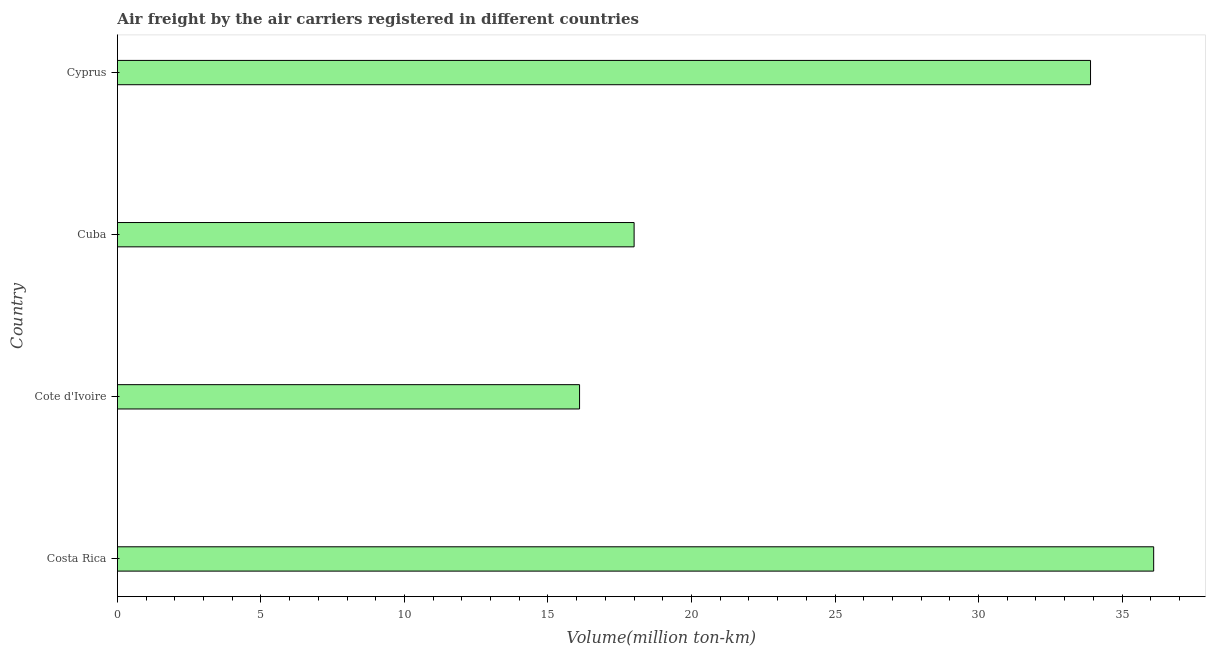What is the title of the graph?
Provide a succinct answer. Air freight by the air carriers registered in different countries. What is the label or title of the X-axis?
Keep it short and to the point. Volume(million ton-km). What is the air freight in Cote d'Ivoire?
Make the answer very short. 16.1. Across all countries, what is the maximum air freight?
Offer a terse response. 36.1. Across all countries, what is the minimum air freight?
Your answer should be compact. 16.1. In which country was the air freight minimum?
Make the answer very short. Cote d'Ivoire. What is the sum of the air freight?
Keep it short and to the point. 104.1. What is the difference between the air freight in Cote d'Ivoire and Cyprus?
Provide a short and direct response. -17.8. What is the average air freight per country?
Provide a succinct answer. 26.02. What is the median air freight?
Your response must be concise. 25.95. In how many countries, is the air freight greater than 2 million ton-km?
Ensure brevity in your answer.  4. What is the ratio of the air freight in Cote d'Ivoire to that in Cuba?
Give a very brief answer. 0.89. Is the air freight in Cote d'Ivoire less than that in Cyprus?
Provide a short and direct response. Yes. What is the difference between the highest and the second highest air freight?
Provide a succinct answer. 2.2. In how many countries, is the air freight greater than the average air freight taken over all countries?
Offer a very short reply. 2. How many bars are there?
Your answer should be compact. 4. Are all the bars in the graph horizontal?
Your response must be concise. Yes. What is the difference between two consecutive major ticks on the X-axis?
Give a very brief answer. 5. Are the values on the major ticks of X-axis written in scientific E-notation?
Provide a succinct answer. No. What is the Volume(million ton-km) in Costa Rica?
Provide a short and direct response. 36.1. What is the Volume(million ton-km) in Cote d'Ivoire?
Make the answer very short. 16.1. What is the Volume(million ton-km) in Cyprus?
Keep it short and to the point. 33.9. What is the difference between the Volume(million ton-km) in Costa Rica and Cote d'Ivoire?
Your response must be concise. 20. What is the difference between the Volume(million ton-km) in Costa Rica and Cuba?
Provide a short and direct response. 18.1. What is the difference between the Volume(million ton-km) in Cote d'Ivoire and Cuba?
Provide a short and direct response. -1.9. What is the difference between the Volume(million ton-km) in Cote d'Ivoire and Cyprus?
Offer a terse response. -17.8. What is the difference between the Volume(million ton-km) in Cuba and Cyprus?
Keep it short and to the point. -15.9. What is the ratio of the Volume(million ton-km) in Costa Rica to that in Cote d'Ivoire?
Offer a very short reply. 2.24. What is the ratio of the Volume(million ton-km) in Costa Rica to that in Cuba?
Give a very brief answer. 2.01. What is the ratio of the Volume(million ton-km) in Costa Rica to that in Cyprus?
Your response must be concise. 1.06. What is the ratio of the Volume(million ton-km) in Cote d'Ivoire to that in Cuba?
Ensure brevity in your answer.  0.89. What is the ratio of the Volume(million ton-km) in Cote d'Ivoire to that in Cyprus?
Your response must be concise. 0.47. What is the ratio of the Volume(million ton-km) in Cuba to that in Cyprus?
Your answer should be very brief. 0.53. 